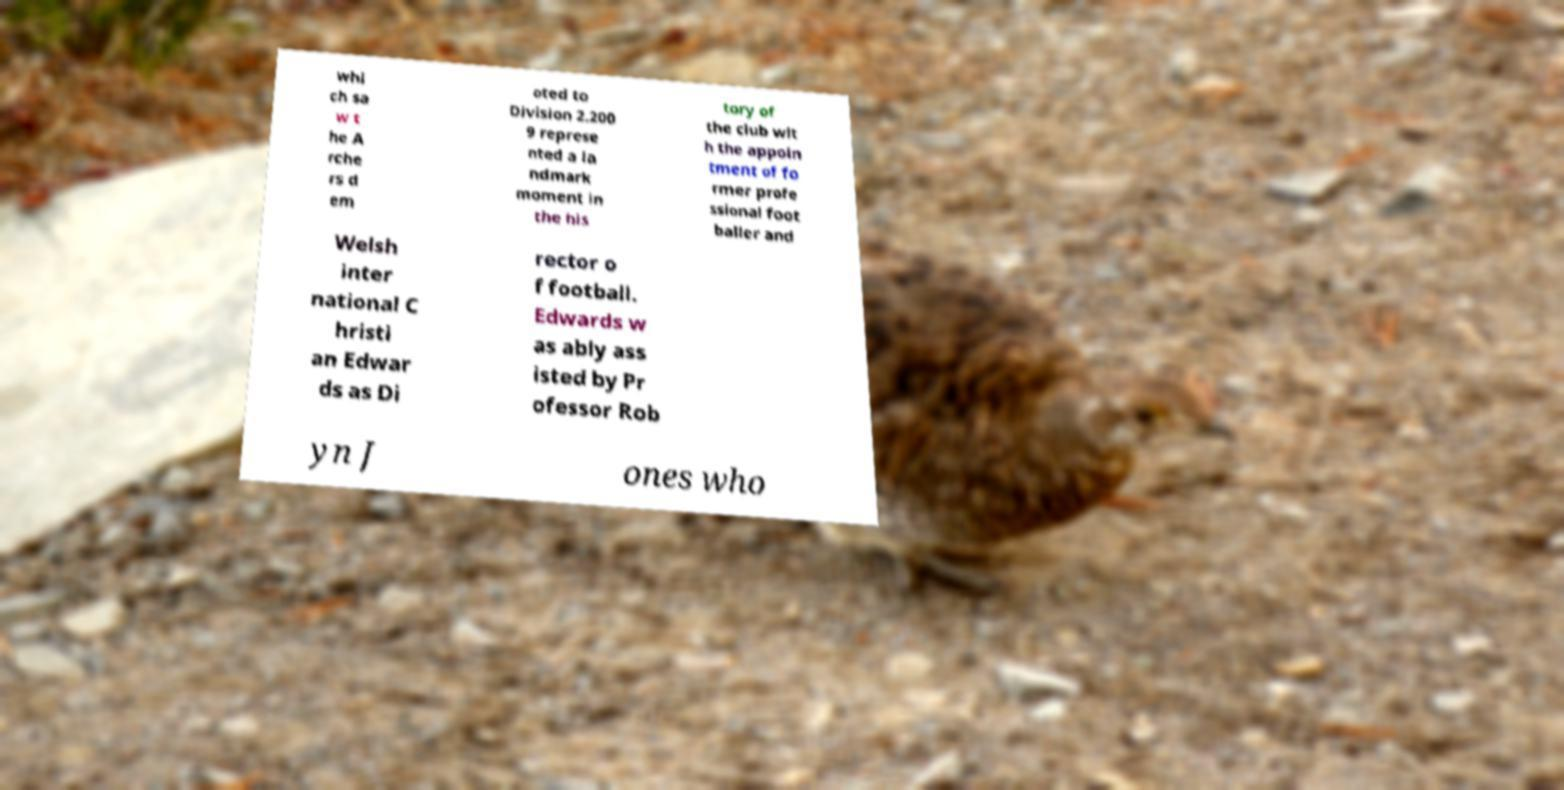Can you accurately transcribe the text from the provided image for me? whi ch sa w t he A rche rs d em oted to Division 2.200 9 represe nted a la ndmark moment in the his tory of the club wit h the appoin tment of fo rmer profe ssional foot baller and Welsh inter national C hristi an Edwar ds as Di rector o f football. Edwards w as ably ass isted by Pr ofessor Rob yn J ones who 